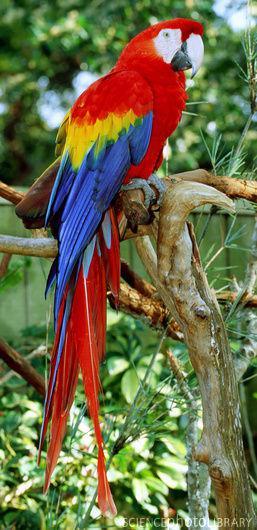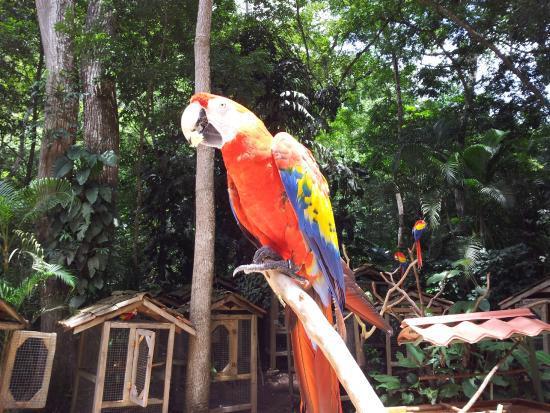The first image is the image on the left, the second image is the image on the right. Considering the images on both sides, is "The image on the right contains only one parrot." valid? Answer yes or no. Yes. 